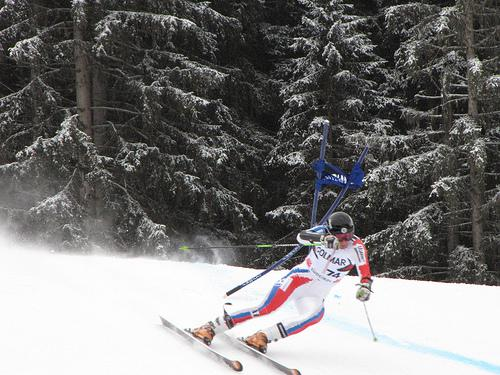Question: where is the skiing happening?
Choices:
A. At a resort.
B. On the hill.
C. Mountain.
D. On the snow.
Answer with the letter. Answer: C Question: when will the man stop?
Choices:
A. Bottom.
B. When he reaches the corner.
C. When the clock hits zero.
D. If he falls.
Answer with the letter. Answer: A Question: who is skiing down hill?
Choices:
A. A woman.
B. A man.
C. A boy.
D. A girl.
Answer with the letter. Answer: B Question: how do the skis attach?
Choices:
A. Straps.
B. Buckles.
C. Belts.
D. Locks.
Answer with the letter. Answer: A Question: where do the skis work?
Choices:
A. Mountain.
B. Hill.
C. Slope.
D. Snow.
Answer with the letter. Answer: D 